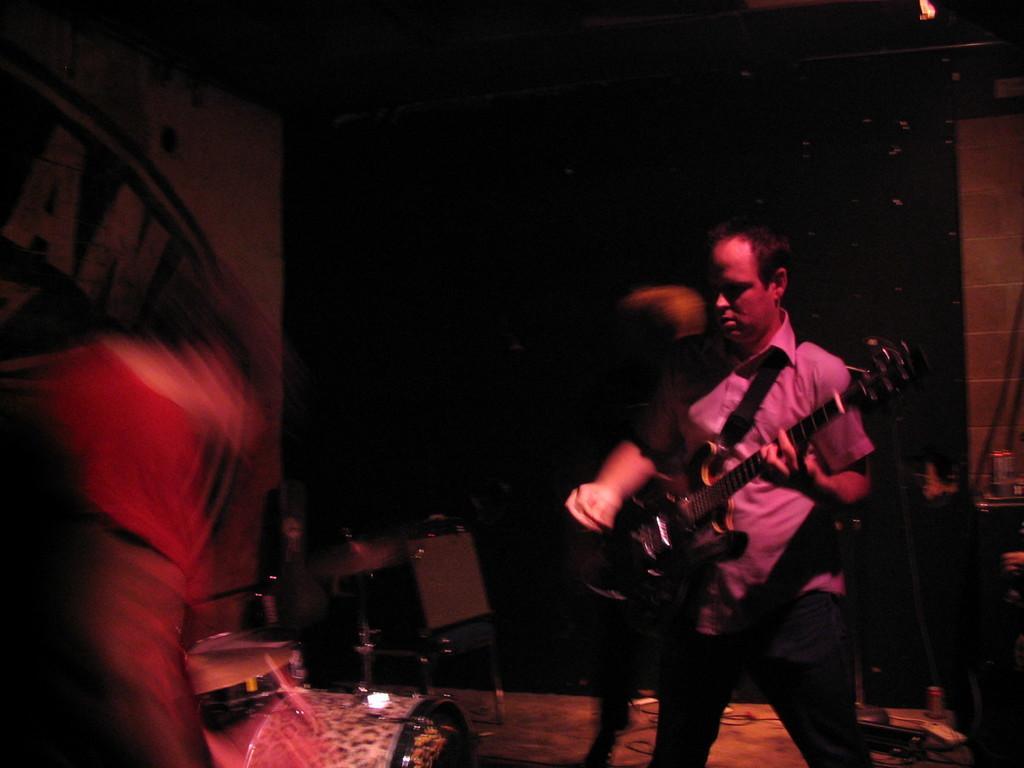Please provide a concise description of this image. a person is standing, holding a guitar. behind him there is a black background. he is wearing a shirt and a pant. 